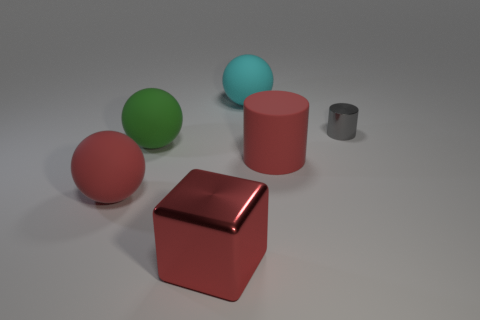Are there more large green rubber things right of the red metal thing than cylinders?
Provide a short and direct response. No. What number of other objects are the same size as the metal cube?
Provide a succinct answer. 4. How many gray cylinders are behind the cyan rubber ball?
Give a very brief answer. 0. Is the number of large spheres that are right of the rubber cylinder the same as the number of red things on the right side of the green rubber ball?
Keep it short and to the point. No. There is another rubber thing that is the same shape as the gray object; what is its size?
Make the answer very short. Large. What is the shape of the big red rubber object to the left of the large red cube?
Provide a succinct answer. Sphere. Do the small gray object behind the cube and the large red object to the right of the big red shiny object have the same material?
Provide a short and direct response. No. What is the shape of the tiny gray object?
Provide a succinct answer. Cylinder. Are there the same number of green matte things on the right side of the large red cube and metal objects?
Provide a succinct answer. No. What is the size of the cylinder that is the same color as the shiny cube?
Your response must be concise. Large. 